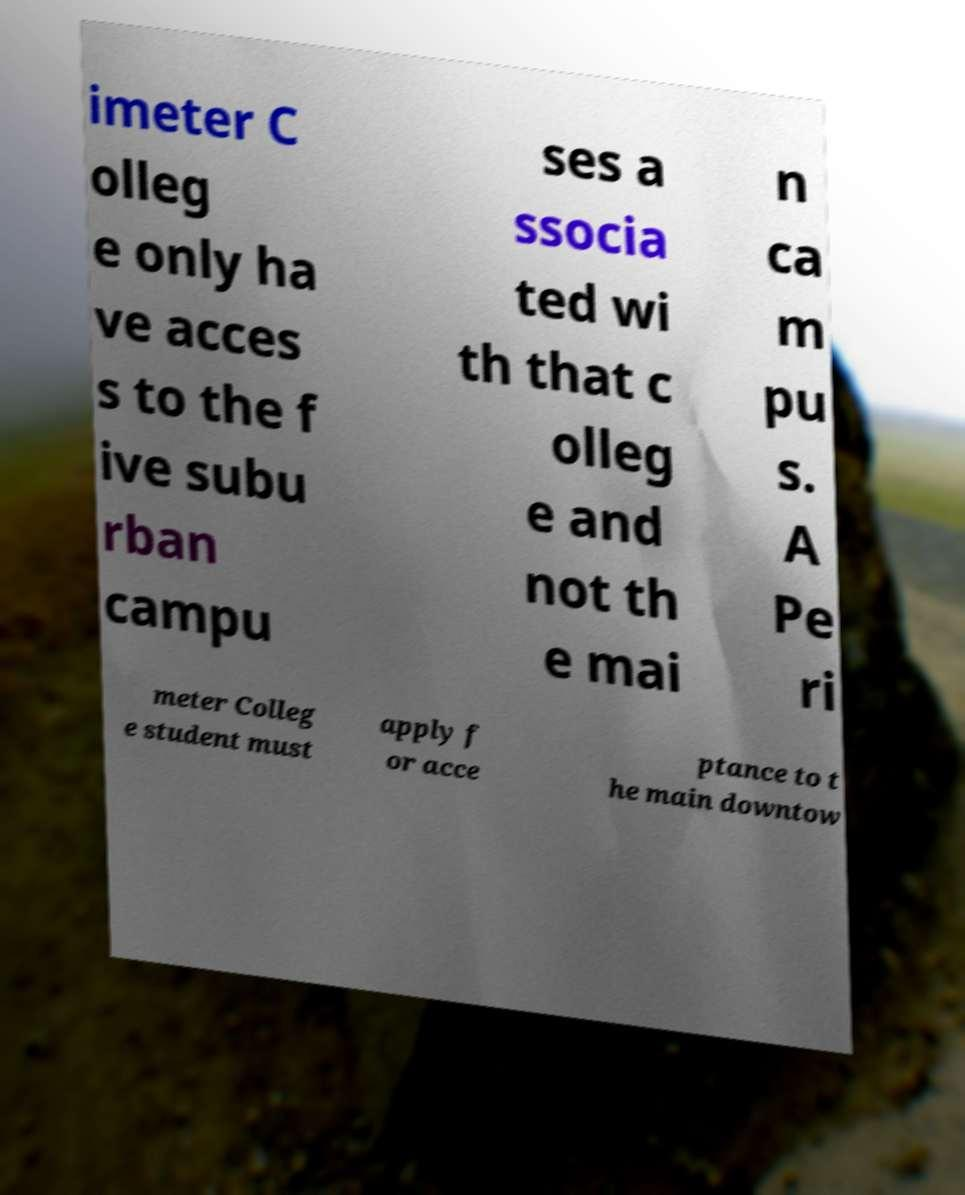What messages or text are displayed in this image? I need them in a readable, typed format. imeter C olleg e only ha ve acces s to the f ive subu rban campu ses a ssocia ted wi th that c olleg e and not th e mai n ca m pu s. A Pe ri meter Colleg e student must apply f or acce ptance to t he main downtow 